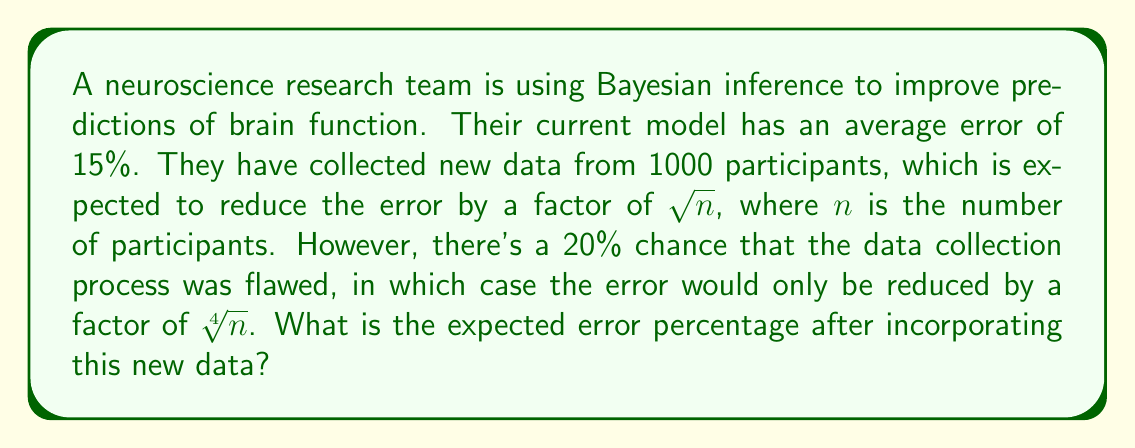Can you answer this question? Let's approach this step-by-step:

1) First, let's calculate the error reduction factor for both scenarios:
   - Normal case: $\sqrt{1000} = 10\sqrt{10} \approx 31.62$
   - Flawed case: $\sqrt[4]{1000} = \sqrt[4]{10^3} = 10^{3/4} \approx 5.62$

2) Now, let's calculate the new error percentage for both scenarios:
   - Normal case: $\frac{15\%}{31.62} \approx 0.4744\%$
   - Flawed case: $\frac{15\%}{5.62} \approx 2.6690\%$

3) We can now set up our expected value calculation:
   $$E(\text{error}) = 0.8 \cdot 0.4744\% + 0.2 \cdot 2.6690\%$$

4) Let's compute this:
   $$E(\text{error}) = 0.37952\% + 0.53380\% = 0.91332\%$$

5) Rounding to two decimal places:
   $$E(\text{error}) \approx 0.91\%$$
Answer: 0.91% 